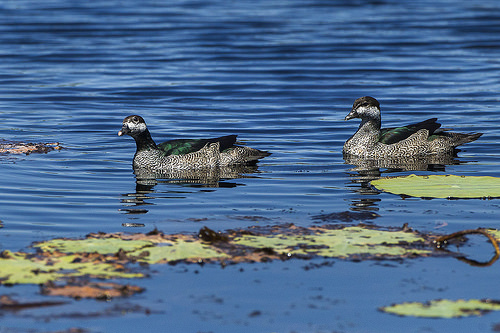<image>
Is the water on the bird? No. The water is not positioned on the bird. They may be near each other, but the water is not supported by or resting on top of the bird. Where is the ducks in relation to the water? Is it in the water? Yes. The ducks is contained within or inside the water, showing a containment relationship. 